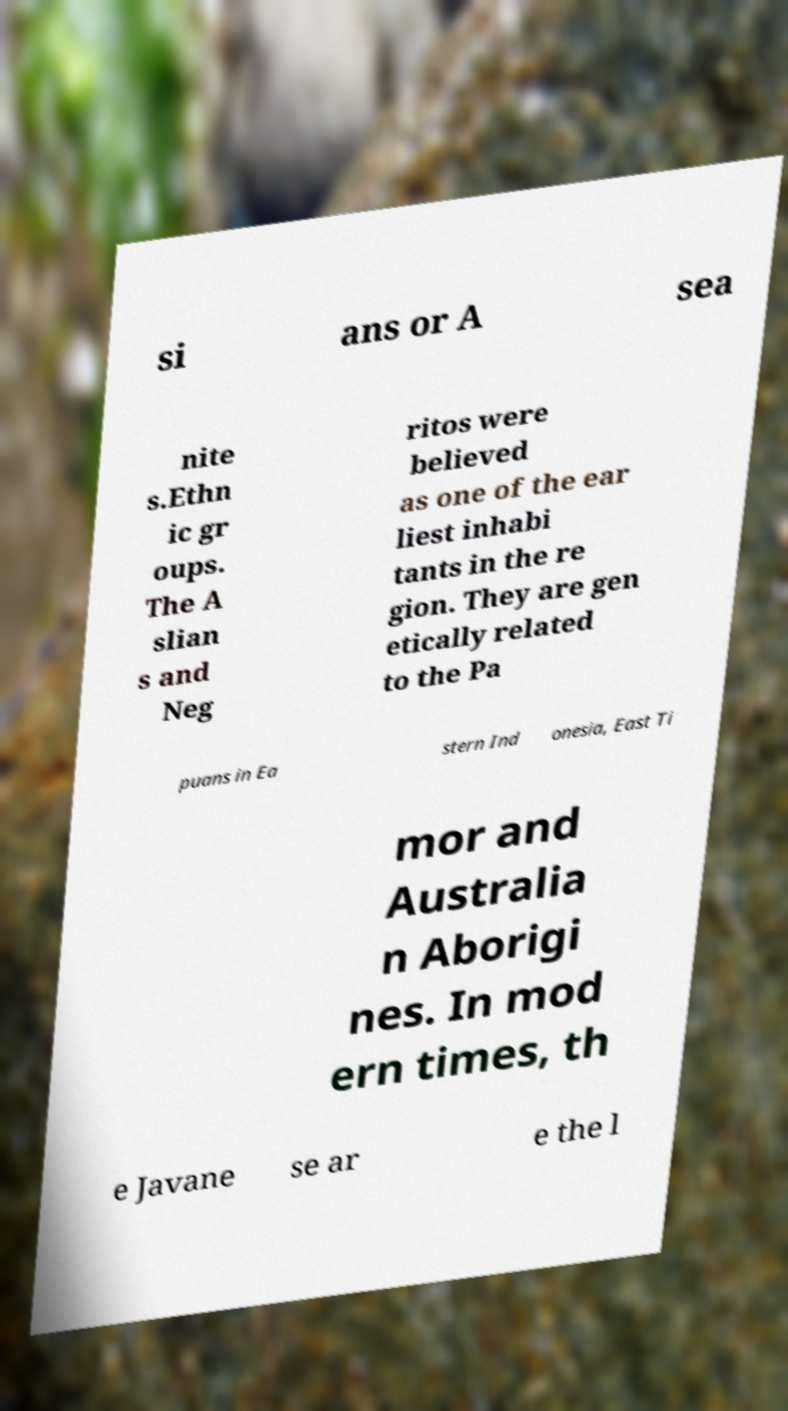I need the written content from this picture converted into text. Can you do that? si ans or A sea nite s.Ethn ic gr oups. The A slian s and Neg ritos were believed as one of the ear liest inhabi tants in the re gion. They are gen etically related to the Pa puans in Ea stern Ind onesia, East Ti mor and Australia n Aborigi nes. In mod ern times, th e Javane se ar e the l 